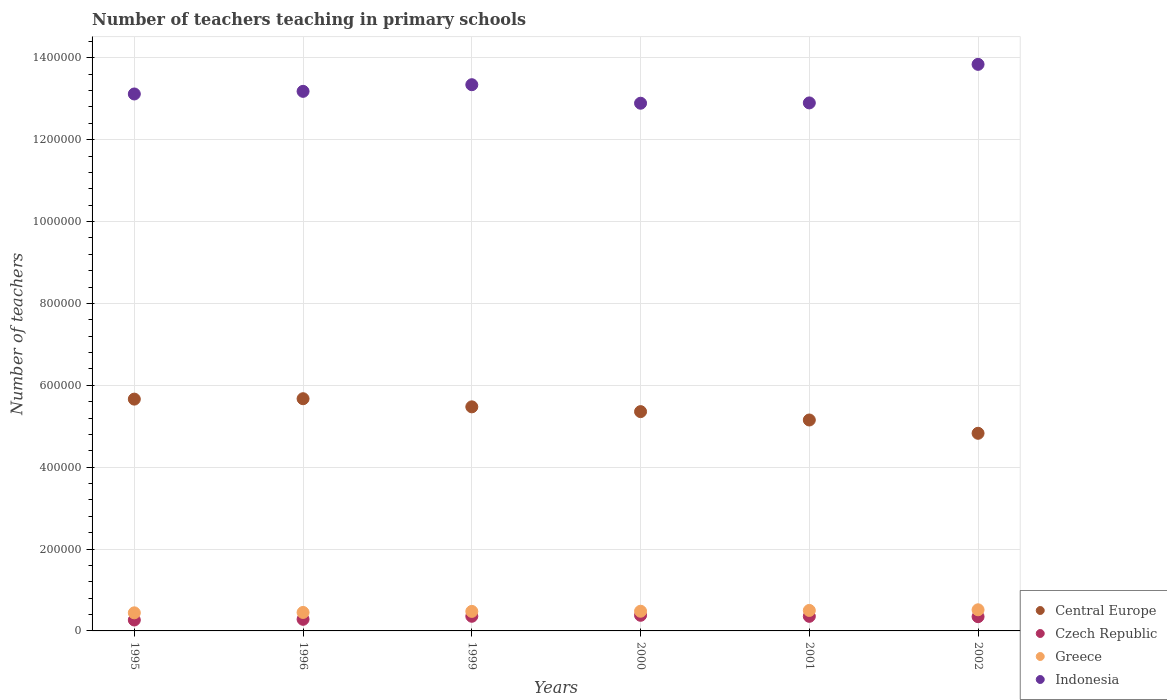Is the number of dotlines equal to the number of legend labels?
Make the answer very short. Yes. What is the number of teachers teaching in primary schools in Central Europe in 2001?
Offer a terse response. 5.15e+05. Across all years, what is the maximum number of teachers teaching in primary schools in Central Europe?
Give a very brief answer. 5.67e+05. Across all years, what is the minimum number of teachers teaching in primary schools in Central Europe?
Provide a succinct answer. 4.83e+05. In which year was the number of teachers teaching in primary schools in Greece minimum?
Give a very brief answer. 1995. What is the total number of teachers teaching in primary schools in Greece in the graph?
Give a very brief answer. 2.87e+05. What is the difference between the number of teachers teaching in primary schools in Indonesia in 1999 and that in 2000?
Make the answer very short. 4.52e+04. What is the difference between the number of teachers teaching in primary schools in Central Europe in 1995 and the number of teachers teaching in primary schools in Greece in 2000?
Your answer should be compact. 5.18e+05. What is the average number of teachers teaching in primary schools in Greece per year?
Ensure brevity in your answer.  4.78e+04. In the year 2001, what is the difference between the number of teachers teaching in primary schools in Czech Republic and number of teachers teaching in primary schools in Greece?
Provide a succinct answer. -1.44e+04. In how many years, is the number of teachers teaching in primary schools in Indonesia greater than 840000?
Ensure brevity in your answer.  6. What is the ratio of the number of teachers teaching in primary schools in Greece in 2001 to that in 2002?
Make the answer very short. 0.97. Is the difference between the number of teachers teaching in primary schools in Czech Republic in 1995 and 1996 greater than the difference between the number of teachers teaching in primary schools in Greece in 1995 and 1996?
Provide a succinct answer. No. What is the difference between the highest and the second highest number of teachers teaching in primary schools in Czech Republic?
Offer a terse response. 2410. What is the difference between the highest and the lowest number of teachers teaching in primary schools in Czech Republic?
Provide a short and direct response. 1.15e+04. Is it the case that in every year, the sum of the number of teachers teaching in primary schools in Greece and number of teachers teaching in primary schools in Central Europe  is greater than the sum of number of teachers teaching in primary schools in Czech Republic and number of teachers teaching in primary schools in Indonesia?
Ensure brevity in your answer.  Yes. Does the number of teachers teaching in primary schools in Indonesia monotonically increase over the years?
Your answer should be very brief. No. Is the number of teachers teaching in primary schools in Czech Republic strictly less than the number of teachers teaching in primary schools in Indonesia over the years?
Ensure brevity in your answer.  Yes. How many dotlines are there?
Provide a short and direct response. 4. How many years are there in the graph?
Your response must be concise. 6. What is the difference between two consecutive major ticks on the Y-axis?
Your answer should be compact. 2.00e+05. Does the graph contain grids?
Your response must be concise. Yes. What is the title of the graph?
Your response must be concise. Number of teachers teaching in primary schools. What is the label or title of the X-axis?
Ensure brevity in your answer.  Years. What is the label or title of the Y-axis?
Ensure brevity in your answer.  Number of teachers. What is the Number of teachers in Central Europe in 1995?
Provide a short and direct response. 5.66e+05. What is the Number of teachers of Czech Republic in 1995?
Provide a succinct answer. 2.67e+04. What is the Number of teachers in Greece in 1995?
Your answer should be compact. 4.42e+04. What is the Number of teachers in Indonesia in 1995?
Your answer should be compact. 1.31e+06. What is the Number of teachers of Central Europe in 1996?
Offer a terse response. 5.67e+05. What is the Number of teachers in Czech Republic in 1996?
Your response must be concise. 2.84e+04. What is the Number of teachers of Greece in 1996?
Your response must be concise. 4.51e+04. What is the Number of teachers in Indonesia in 1996?
Offer a terse response. 1.32e+06. What is the Number of teachers of Central Europe in 1999?
Ensure brevity in your answer.  5.47e+05. What is the Number of teachers of Czech Republic in 1999?
Your response must be concise. 3.58e+04. What is the Number of teachers of Greece in 1999?
Give a very brief answer. 4.77e+04. What is the Number of teachers of Indonesia in 1999?
Provide a short and direct response. 1.33e+06. What is the Number of teachers in Central Europe in 2000?
Keep it short and to the point. 5.36e+05. What is the Number of teachers in Czech Republic in 2000?
Your answer should be very brief. 3.82e+04. What is the Number of teachers of Greece in 2000?
Make the answer very short. 4.81e+04. What is the Number of teachers in Indonesia in 2000?
Provide a succinct answer. 1.29e+06. What is the Number of teachers of Central Europe in 2001?
Your response must be concise. 5.15e+05. What is the Number of teachers of Czech Republic in 2001?
Offer a terse response. 3.56e+04. What is the Number of teachers in Greece in 2001?
Give a very brief answer. 5.00e+04. What is the Number of teachers in Indonesia in 2001?
Make the answer very short. 1.29e+06. What is the Number of teachers of Central Europe in 2002?
Your answer should be very brief. 4.83e+05. What is the Number of teachers in Czech Republic in 2002?
Make the answer very short. 3.48e+04. What is the Number of teachers of Greece in 2002?
Your answer should be compact. 5.16e+04. What is the Number of teachers of Indonesia in 2002?
Your response must be concise. 1.38e+06. Across all years, what is the maximum Number of teachers in Central Europe?
Your answer should be very brief. 5.67e+05. Across all years, what is the maximum Number of teachers in Czech Republic?
Provide a succinct answer. 3.82e+04. Across all years, what is the maximum Number of teachers of Greece?
Keep it short and to the point. 5.16e+04. Across all years, what is the maximum Number of teachers in Indonesia?
Your answer should be compact. 1.38e+06. Across all years, what is the minimum Number of teachers of Central Europe?
Your answer should be compact. 4.83e+05. Across all years, what is the minimum Number of teachers in Czech Republic?
Offer a very short reply. 2.67e+04. Across all years, what is the minimum Number of teachers in Greece?
Provide a short and direct response. 4.42e+04. Across all years, what is the minimum Number of teachers in Indonesia?
Make the answer very short. 1.29e+06. What is the total Number of teachers in Central Europe in the graph?
Your answer should be very brief. 3.21e+06. What is the total Number of teachers in Czech Republic in the graph?
Offer a very short reply. 1.99e+05. What is the total Number of teachers of Greece in the graph?
Your response must be concise. 2.87e+05. What is the total Number of teachers of Indonesia in the graph?
Your answer should be very brief. 7.93e+06. What is the difference between the Number of teachers of Central Europe in 1995 and that in 1996?
Provide a short and direct response. -986.69. What is the difference between the Number of teachers of Czech Republic in 1995 and that in 1996?
Give a very brief answer. -1667. What is the difference between the Number of teachers in Greece in 1995 and that in 1996?
Make the answer very short. -960. What is the difference between the Number of teachers in Indonesia in 1995 and that in 1996?
Ensure brevity in your answer.  -6405. What is the difference between the Number of teachers of Central Europe in 1995 and that in 1999?
Your answer should be very brief. 1.89e+04. What is the difference between the Number of teachers of Czech Republic in 1995 and that in 1999?
Offer a terse response. -9097. What is the difference between the Number of teachers in Greece in 1995 and that in 1999?
Make the answer very short. -3516. What is the difference between the Number of teachers in Indonesia in 1995 and that in 1999?
Ensure brevity in your answer.  -2.26e+04. What is the difference between the Number of teachers in Central Europe in 1995 and that in 2000?
Keep it short and to the point. 3.05e+04. What is the difference between the Number of teachers in Czech Republic in 1995 and that in 2000?
Offer a very short reply. -1.15e+04. What is the difference between the Number of teachers of Greece in 1995 and that in 2000?
Offer a very short reply. -3936. What is the difference between the Number of teachers in Indonesia in 1995 and that in 2000?
Offer a very short reply. 2.26e+04. What is the difference between the Number of teachers of Central Europe in 1995 and that in 2001?
Ensure brevity in your answer.  5.10e+04. What is the difference between the Number of teachers in Czech Republic in 1995 and that in 2001?
Offer a terse response. -8922. What is the difference between the Number of teachers of Greece in 1995 and that in 2001?
Give a very brief answer. -5844. What is the difference between the Number of teachers in Indonesia in 1995 and that in 2001?
Your response must be concise. 2.19e+04. What is the difference between the Number of teachers in Central Europe in 1995 and that in 2002?
Make the answer very short. 8.35e+04. What is the difference between the Number of teachers of Czech Republic in 1995 and that in 2002?
Offer a very short reply. -8106. What is the difference between the Number of teachers in Greece in 1995 and that in 2002?
Your response must be concise. -7438. What is the difference between the Number of teachers in Indonesia in 1995 and that in 2002?
Offer a very short reply. -7.23e+04. What is the difference between the Number of teachers of Central Europe in 1996 and that in 1999?
Give a very brief answer. 1.99e+04. What is the difference between the Number of teachers in Czech Republic in 1996 and that in 1999?
Your response must be concise. -7430. What is the difference between the Number of teachers in Greece in 1996 and that in 1999?
Provide a short and direct response. -2556. What is the difference between the Number of teachers in Indonesia in 1996 and that in 1999?
Offer a terse response. -1.62e+04. What is the difference between the Number of teachers in Central Europe in 1996 and that in 2000?
Provide a short and direct response. 3.15e+04. What is the difference between the Number of teachers of Czech Republic in 1996 and that in 2000?
Give a very brief answer. -9840. What is the difference between the Number of teachers in Greece in 1996 and that in 2000?
Offer a terse response. -2976. What is the difference between the Number of teachers of Indonesia in 1996 and that in 2000?
Keep it short and to the point. 2.90e+04. What is the difference between the Number of teachers of Central Europe in 1996 and that in 2001?
Keep it short and to the point. 5.20e+04. What is the difference between the Number of teachers of Czech Republic in 1996 and that in 2001?
Offer a very short reply. -7255. What is the difference between the Number of teachers of Greece in 1996 and that in 2001?
Ensure brevity in your answer.  -4884. What is the difference between the Number of teachers in Indonesia in 1996 and that in 2001?
Give a very brief answer. 2.83e+04. What is the difference between the Number of teachers of Central Europe in 1996 and that in 2002?
Your response must be concise. 8.45e+04. What is the difference between the Number of teachers in Czech Republic in 1996 and that in 2002?
Ensure brevity in your answer.  -6439. What is the difference between the Number of teachers of Greece in 1996 and that in 2002?
Your answer should be compact. -6478. What is the difference between the Number of teachers in Indonesia in 1996 and that in 2002?
Your response must be concise. -6.59e+04. What is the difference between the Number of teachers of Central Europe in 1999 and that in 2000?
Your answer should be compact. 1.17e+04. What is the difference between the Number of teachers in Czech Republic in 1999 and that in 2000?
Keep it short and to the point. -2410. What is the difference between the Number of teachers in Greece in 1999 and that in 2000?
Your response must be concise. -420. What is the difference between the Number of teachers in Indonesia in 1999 and that in 2000?
Offer a very short reply. 4.52e+04. What is the difference between the Number of teachers in Central Europe in 1999 and that in 2001?
Your answer should be very brief. 3.21e+04. What is the difference between the Number of teachers of Czech Republic in 1999 and that in 2001?
Your answer should be very brief. 175. What is the difference between the Number of teachers in Greece in 1999 and that in 2001?
Provide a succinct answer. -2328. What is the difference between the Number of teachers in Indonesia in 1999 and that in 2001?
Your response must be concise. 4.45e+04. What is the difference between the Number of teachers of Central Europe in 1999 and that in 2002?
Offer a very short reply. 6.46e+04. What is the difference between the Number of teachers of Czech Republic in 1999 and that in 2002?
Give a very brief answer. 991. What is the difference between the Number of teachers in Greece in 1999 and that in 2002?
Provide a short and direct response. -3922. What is the difference between the Number of teachers in Indonesia in 1999 and that in 2002?
Give a very brief answer. -4.97e+04. What is the difference between the Number of teachers in Central Europe in 2000 and that in 2001?
Offer a terse response. 2.04e+04. What is the difference between the Number of teachers in Czech Republic in 2000 and that in 2001?
Give a very brief answer. 2585. What is the difference between the Number of teachers in Greece in 2000 and that in 2001?
Provide a succinct answer. -1908. What is the difference between the Number of teachers of Indonesia in 2000 and that in 2001?
Make the answer very short. -755. What is the difference between the Number of teachers of Central Europe in 2000 and that in 2002?
Ensure brevity in your answer.  5.29e+04. What is the difference between the Number of teachers in Czech Republic in 2000 and that in 2002?
Ensure brevity in your answer.  3401. What is the difference between the Number of teachers of Greece in 2000 and that in 2002?
Offer a very short reply. -3502. What is the difference between the Number of teachers in Indonesia in 2000 and that in 2002?
Keep it short and to the point. -9.49e+04. What is the difference between the Number of teachers of Central Europe in 2001 and that in 2002?
Keep it short and to the point. 3.25e+04. What is the difference between the Number of teachers in Czech Republic in 2001 and that in 2002?
Your answer should be compact. 816. What is the difference between the Number of teachers of Greece in 2001 and that in 2002?
Provide a succinct answer. -1594. What is the difference between the Number of teachers in Indonesia in 2001 and that in 2002?
Make the answer very short. -9.42e+04. What is the difference between the Number of teachers of Central Europe in 1995 and the Number of teachers of Czech Republic in 1996?
Offer a very short reply. 5.38e+05. What is the difference between the Number of teachers in Central Europe in 1995 and the Number of teachers in Greece in 1996?
Provide a short and direct response. 5.21e+05. What is the difference between the Number of teachers in Central Europe in 1995 and the Number of teachers in Indonesia in 1996?
Keep it short and to the point. -7.52e+05. What is the difference between the Number of teachers in Czech Republic in 1995 and the Number of teachers in Greece in 1996?
Provide a short and direct response. -1.84e+04. What is the difference between the Number of teachers of Czech Republic in 1995 and the Number of teachers of Indonesia in 1996?
Give a very brief answer. -1.29e+06. What is the difference between the Number of teachers of Greece in 1995 and the Number of teachers of Indonesia in 1996?
Provide a succinct answer. -1.27e+06. What is the difference between the Number of teachers of Central Europe in 1995 and the Number of teachers of Czech Republic in 1999?
Your response must be concise. 5.30e+05. What is the difference between the Number of teachers of Central Europe in 1995 and the Number of teachers of Greece in 1999?
Your answer should be very brief. 5.19e+05. What is the difference between the Number of teachers in Central Europe in 1995 and the Number of teachers in Indonesia in 1999?
Your answer should be compact. -7.68e+05. What is the difference between the Number of teachers of Czech Republic in 1995 and the Number of teachers of Greece in 1999?
Offer a terse response. -2.10e+04. What is the difference between the Number of teachers in Czech Republic in 1995 and the Number of teachers in Indonesia in 1999?
Your answer should be compact. -1.31e+06. What is the difference between the Number of teachers in Greece in 1995 and the Number of teachers in Indonesia in 1999?
Ensure brevity in your answer.  -1.29e+06. What is the difference between the Number of teachers of Central Europe in 1995 and the Number of teachers of Czech Republic in 2000?
Your answer should be compact. 5.28e+05. What is the difference between the Number of teachers of Central Europe in 1995 and the Number of teachers of Greece in 2000?
Provide a succinct answer. 5.18e+05. What is the difference between the Number of teachers of Central Europe in 1995 and the Number of teachers of Indonesia in 2000?
Make the answer very short. -7.23e+05. What is the difference between the Number of teachers in Czech Republic in 1995 and the Number of teachers in Greece in 2000?
Your answer should be compact. -2.14e+04. What is the difference between the Number of teachers of Czech Republic in 1995 and the Number of teachers of Indonesia in 2000?
Your answer should be compact. -1.26e+06. What is the difference between the Number of teachers of Greece in 1995 and the Number of teachers of Indonesia in 2000?
Keep it short and to the point. -1.24e+06. What is the difference between the Number of teachers in Central Europe in 1995 and the Number of teachers in Czech Republic in 2001?
Your answer should be compact. 5.31e+05. What is the difference between the Number of teachers in Central Europe in 1995 and the Number of teachers in Greece in 2001?
Provide a short and direct response. 5.16e+05. What is the difference between the Number of teachers in Central Europe in 1995 and the Number of teachers in Indonesia in 2001?
Your response must be concise. -7.24e+05. What is the difference between the Number of teachers in Czech Republic in 1995 and the Number of teachers in Greece in 2001?
Offer a very short reply. -2.33e+04. What is the difference between the Number of teachers in Czech Republic in 1995 and the Number of teachers in Indonesia in 2001?
Offer a terse response. -1.26e+06. What is the difference between the Number of teachers in Greece in 1995 and the Number of teachers in Indonesia in 2001?
Make the answer very short. -1.25e+06. What is the difference between the Number of teachers in Central Europe in 1995 and the Number of teachers in Czech Republic in 2002?
Make the answer very short. 5.31e+05. What is the difference between the Number of teachers in Central Europe in 1995 and the Number of teachers in Greece in 2002?
Ensure brevity in your answer.  5.15e+05. What is the difference between the Number of teachers of Central Europe in 1995 and the Number of teachers of Indonesia in 2002?
Provide a succinct answer. -8.18e+05. What is the difference between the Number of teachers of Czech Republic in 1995 and the Number of teachers of Greece in 2002?
Provide a short and direct response. -2.49e+04. What is the difference between the Number of teachers of Czech Republic in 1995 and the Number of teachers of Indonesia in 2002?
Offer a terse response. -1.36e+06. What is the difference between the Number of teachers of Greece in 1995 and the Number of teachers of Indonesia in 2002?
Offer a very short reply. -1.34e+06. What is the difference between the Number of teachers of Central Europe in 1996 and the Number of teachers of Czech Republic in 1999?
Give a very brief answer. 5.31e+05. What is the difference between the Number of teachers in Central Europe in 1996 and the Number of teachers in Greece in 1999?
Your answer should be compact. 5.20e+05. What is the difference between the Number of teachers of Central Europe in 1996 and the Number of teachers of Indonesia in 1999?
Provide a succinct answer. -7.67e+05. What is the difference between the Number of teachers in Czech Republic in 1996 and the Number of teachers in Greece in 1999?
Give a very brief answer. -1.93e+04. What is the difference between the Number of teachers of Czech Republic in 1996 and the Number of teachers of Indonesia in 1999?
Offer a terse response. -1.31e+06. What is the difference between the Number of teachers in Greece in 1996 and the Number of teachers in Indonesia in 1999?
Provide a short and direct response. -1.29e+06. What is the difference between the Number of teachers in Central Europe in 1996 and the Number of teachers in Czech Republic in 2000?
Provide a short and direct response. 5.29e+05. What is the difference between the Number of teachers in Central Europe in 1996 and the Number of teachers in Greece in 2000?
Make the answer very short. 5.19e+05. What is the difference between the Number of teachers in Central Europe in 1996 and the Number of teachers in Indonesia in 2000?
Offer a very short reply. -7.22e+05. What is the difference between the Number of teachers in Czech Republic in 1996 and the Number of teachers in Greece in 2000?
Give a very brief answer. -1.97e+04. What is the difference between the Number of teachers of Czech Republic in 1996 and the Number of teachers of Indonesia in 2000?
Your answer should be compact. -1.26e+06. What is the difference between the Number of teachers of Greece in 1996 and the Number of teachers of Indonesia in 2000?
Keep it short and to the point. -1.24e+06. What is the difference between the Number of teachers of Central Europe in 1996 and the Number of teachers of Czech Republic in 2001?
Provide a succinct answer. 5.32e+05. What is the difference between the Number of teachers in Central Europe in 1996 and the Number of teachers in Greece in 2001?
Provide a short and direct response. 5.17e+05. What is the difference between the Number of teachers of Central Europe in 1996 and the Number of teachers of Indonesia in 2001?
Keep it short and to the point. -7.23e+05. What is the difference between the Number of teachers in Czech Republic in 1996 and the Number of teachers in Greece in 2001?
Keep it short and to the point. -2.17e+04. What is the difference between the Number of teachers of Czech Republic in 1996 and the Number of teachers of Indonesia in 2001?
Give a very brief answer. -1.26e+06. What is the difference between the Number of teachers in Greece in 1996 and the Number of teachers in Indonesia in 2001?
Keep it short and to the point. -1.24e+06. What is the difference between the Number of teachers of Central Europe in 1996 and the Number of teachers of Czech Republic in 2002?
Make the answer very short. 5.32e+05. What is the difference between the Number of teachers in Central Europe in 1996 and the Number of teachers in Greece in 2002?
Make the answer very short. 5.16e+05. What is the difference between the Number of teachers in Central Europe in 1996 and the Number of teachers in Indonesia in 2002?
Make the answer very short. -8.17e+05. What is the difference between the Number of teachers in Czech Republic in 1996 and the Number of teachers in Greece in 2002?
Your answer should be very brief. -2.32e+04. What is the difference between the Number of teachers of Czech Republic in 1996 and the Number of teachers of Indonesia in 2002?
Your answer should be very brief. -1.36e+06. What is the difference between the Number of teachers in Greece in 1996 and the Number of teachers in Indonesia in 2002?
Make the answer very short. -1.34e+06. What is the difference between the Number of teachers of Central Europe in 1999 and the Number of teachers of Czech Republic in 2000?
Make the answer very short. 5.09e+05. What is the difference between the Number of teachers in Central Europe in 1999 and the Number of teachers in Greece in 2000?
Offer a terse response. 4.99e+05. What is the difference between the Number of teachers of Central Europe in 1999 and the Number of teachers of Indonesia in 2000?
Your answer should be very brief. -7.42e+05. What is the difference between the Number of teachers of Czech Republic in 1999 and the Number of teachers of Greece in 2000?
Ensure brevity in your answer.  -1.23e+04. What is the difference between the Number of teachers of Czech Republic in 1999 and the Number of teachers of Indonesia in 2000?
Provide a succinct answer. -1.25e+06. What is the difference between the Number of teachers in Greece in 1999 and the Number of teachers in Indonesia in 2000?
Your answer should be compact. -1.24e+06. What is the difference between the Number of teachers in Central Europe in 1999 and the Number of teachers in Czech Republic in 2001?
Your answer should be very brief. 5.12e+05. What is the difference between the Number of teachers of Central Europe in 1999 and the Number of teachers of Greece in 2001?
Make the answer very short. 4.97e+05. What is the difference between the Number of teachers of Central Europe in 1999 and the Number of teachers of Indonesia in 2001?
Ensure brevity in your answer.  -7.42e+05. What is the difference between the Number of teachers in Czech Republic in 1999 and the Number of teachers in Greece in 2001?
Make the answer very short. -1.42e+04. What is the difference between the Number of teachers of Czech Republic in 1999 and the Number of teachers of Indonesia in 2001?
Provide a short and direct response. -1.25e+06. What is the difference between the Number of teachers in Greece in 1999 and the Number of teachers in Indonesia in 2001?
Offer a terse response. -1.24e+06. What is the difference between the Number of teachers of Central Europe in 1999 and the Number of teachers of Czech Republic in 2002?
Provide a succinct answer. 5.13e+05. What is the difference between the Number of teachers in Central Europe in 1999 and the Number of teachers in Greece in 2002?
Offer a very short reply. 4.96e+05. What is the difference between the Number of teachers in Central Europe in 1999 and the Number of teachers in Indonesia in 2002?
Your answer should be very brief. -8.37e+05. What is the difference between the Number of teachers in Czech Republic in 1999 and the Number of teachers in Greece in 2002?
Ensure brevity in your answer.  -1.58e+04. What is the difference between the Number of teachers in Czech Republic in 1999 and the Number of teachers in Indonesia in 2002?
Offer a very short reply. -1.35e+06. What is the difference between the Number of teachers in Greece in 1999 and the Number of teachers in Indonesia in 2002?
Ensure brevity in your answer.  -1.34e+06. What is the difference between the Number of teachers in Central Europe in 2000 and the Number of teachers in Czech Republic in 2001?
Provide a short and direct response. 5.00e+05. What is the difference between the Number of teachers of Central Europe in 2000 and the Number of teachers of Greece in 2001?
Make the answer very short. 4.86e+05. What is the difference between the Number of teachers in Central Europe in 2000 and the Number of teachers in Indonesia in 2001?
Offer a terse response. -7.54e+05. What is the difference between the Number of teachers in Czech Republic in 2000 and the Number of teachers in Greece in 2001?
Provide a short and direct response. -1.18e+04. What is the difference between the Number of teachers of Czech Republic in 2000 and the Number of teachers of Indonesia in 2001?
Give a very brief answer. -1.25e+06. What is the difference between the Number of teachers in Greece in 2000 and the Number of teachers in Indonesia in 2001?
Offer a very short reply. -1.24e+06. What is the difference between the Number of teachers in Central Europe in 2000 and the Number of teachers in Czech Republic in 2002?
Provide a succinct answer. 5.01e+05. What is the difference between the Number of teachers of Central Europe in 2000 and the Number of teachers of Greece in 2002?
Ensure brevity in your answer.  4.84e+05. What is the difference between the Number of teachers in Central Europe in 2000 and the Number of teachers in Indonesia in 2002?
Provide a short and direct response. -8.48e+05. What is the difference between the Number of teachers in Czech Republic in 2000 and the Number of teachers in Greece in 2002?
Ensure brevity in your answer.  -1.34e+04. What is the difference between the Number of teachers of Czech Republic in 2000 and the Number of teachers of Indonesia in 2002?
Provide a succinct answer. -1.35e+06. What is the difference between the Number of teachers in Greece in 2000 and the Number of teachers in Indonesia in 2002?
Ensure brevity in your answer.  -1.34e+06. What is the difference between the Number of teachers of Central Europe in 2001 and the Number of teachers of Czech Republic in 2002?
Your response must be concise. 4.80e+05. What is the difference between the Number of teachers in Central Europe in 2001 and the Number of teachers in Greece in 2002?
Your response must be concise. 4.64e+05. What is the difference between the Number of teachers in Central Europe in 2001 and the Number of teachers in Indonesia in 2002?
Provide a succinct answer. -8.69e+05. What is the difference between the Number of teachers of Czech Republic in 2001 and the Number of teachers of Greece in 2002?
Your answer should be very brief. -1.60e+04. What is the difference between the Number of teachers in Czech Republic in 2001 and the Number of teachers in Indonesia in 2002?
Your answer should be very brief. -1.35e+06. What is the difference between the Number of teachers in Greece in 2001 and the Number of teachers in Indonesia in 2002?
Make the answer very short. -1.33e+06. What is the average Number of teachers of Central Europe per year?
Your answer should be very brief. 5.36e+05. What is the average Number of teachers of Czech Republic per year?
Your response must be concise. 3.32e+04. What is the average Number of teachers of Greece per year?
Make the answer very short. 4.78e+04. What is the average Number of teachers of Indonesia per year?
Your response must be concise. 1.32e+06. In the year 1995, what is the difference between the Number of teachers in Central Europe and Number of teachers in Czech Republic?
Your answer should be compact. 5.40e+05. In the year 1995, what is the difference between the Number of teachers in Central Europe and Number of teachers in Greece?
Offer a terse response. 5.22e+05. In the year 1995, what is the difference between the Number of teachers of Central Europe and Number of teachers of Indonesia?
Provide a short and direct response. -7.45e+05. In the year 1995, what is the difference between the Number of teachers in Czech Republic and Number of teachers in Greece?
Your response must be concise. -1.75e+04. In the year 1995, what is the difference between the Number of teachers of Czech Republic and Number of teachers of Indonesia?
Your answer should be compact. -1.28e+06. In the year 1995, what is the difference between the Number of teachers in Greece and Number of teachers in Indonesia?
Offer a very short reply. -1.27e+06. In the year 1996, what is the difference between the Number of teachers of Central Europe and Number of teachers of Czech Republic?
Provide a succinct answer. 5.39e+05. In the year 1996, what is the difference between the Number of teachers of Central Europe and Number of teachers of Greece?
Provide a short and direct response. 5.22e+05. In the year 1996, what is the difference between the Number of teachers in Central Europe and Number of teachers in Indonesia?
Provide a short and direct response. -7.51e+05. In the year 1996, what is the difference between the Number of teachers in Czech Republic and Number of teachers in Greece?
Your answer should be compact. -1.68e+04. In the year 1996, what is the difference between the Number of teachers in Czech Republic and Number of teachers in Indonesia?
Provide a succinct answer. -1.29e+06. In the year 1996, what is the difference between the Number of teachers of Greece and Number of teachers of Indonesia?
Offer a very short reply. -1.27e+06. In the year 1999, what is the difference between the Number of teachers of Central Europe and Number of teachers of Czech Republic?
Make the answer very short. 5.12e+05. In the year 1999, what is the difference between the Number of teachers of Central Europe and Number of teachers of Greece?
Your answer should be compact. 5.00e+05. In the year 1999, what is the difference between the Number of teachers in Central Europe and Number of teachers in Indonesia?
Provide a short and direct response. -7.87e+05. In the year 1999, what is the difference between the Number of teachers of Czech Republic and Number of teachers of Greece?
Provide a succinct answer. -1.19e+04. In the year 1999, what is the difference between the Number of teachers in Czech Republic and Number of teachers in Indonesia?
Offer a very short reply. -1.30e+06. In the year 1999, what is the difference between the Number of teachers in Greece and Number of teachers in Indonesia?
Make the answer very short. -1.29e+06. In the year 2000, what is the difference between the Number of teachers of Central Europe and Number of teachers of Czech Republic?
Offer a very short reply. 4.97e+05. In the year 2000, what is the difference between the Number of teachers in Central Europe and Number of teachers in Greece?
Offer a terse response. 4.88e+05. In the year 2000, what is the difference between the Number of teachers of Central Europe and Number of teachers of Indonesia?
Your answer should be compact. -7.53e+05. In the year 2000, what is the difference between the Number of teachers of Czech Republic and Number of teachers of Greece?
Provide a short and direct response. -9908. In the year 2000, what is the difference between the Number of teachers in Czech Republic and Number of teachers in Indonesia?
Give a very brief answer. -1.25e+06. In the year 2000, what is the difference between the Number of teachers in Greece and Number of teachers in Indonesia?
Offer a terse response. -1.24e+06. In the year 2001, what is the difference between the Number of teachers in Central Europe and Number of teachers in Czech Republic?
Keep it short and to the point. 4.80e+05. In the year 2001, what is the difference between the Number of teachers of Central Europe and Number of teachers of Greece?
Your response must be concise. 4.65e+05. In the year 2001, what is the difference between the Number of teachers in Central Europe and Number of teachers in Indonesia?
Ensure brevity in your answer.  -7.74e+05. In the year 2001, what is the difference between the Number of teachers in Czech Republic and Number of teachers in Greece?
Make the answer very short. -1.44e+04. In the year 2001, what is the difference between the Number of teachers in Czech Republic and Number of teachers in Indonesia?
Your answer should be very brief. -1.25e+06. In the year 2001, what is the difference between the Number of teachers of Greece and Number of teachers of Indonesia?
Give a very brief answer. -1.24e+06. In the year 2002, what is the difference between the Number of teachers of Central Europe and Number of teachers of Czech Republic?
Provide a short and direct response. 4.48e+05. In the year 2002, what is the difference between the Number of teachers of Central Europe and Number of teachers of Greece?
Your response must be concise. 4.31e+05. In the year 2002, what is the difference between the Number of teachers in Central Europe and Number of teachers in Indonesia?
Ensure brevity in your answer.  -9.01e+05. In the year 2002, what is the difference between the Number of teachers in Czech Republic and Number of teachers in Greece?
Keep it short and to the point. -1.68e+04. In the year 2002, what is the difference between the Number of teachers in Czech Republic and Number of teachers in Indonesia?
Provide a short and direct response. -1.35e+06. In the year 2002, what is the difference between the Number of teachers in Greece and Number of teachers in Indonesia?
Your answer should be compact. -1.33e+06. What is the ratio of the Number of teachers in Greece in 1995 to that in 1996?
Provide a succinct answer. 0.98. What is the ratio of the Number of teachers in Indonesia in 1995 to that in 1996?
Make the answer very short. 1. What is the ratio of the Number of teachers in Central Europe in 1995 to that in 1999?
Keep it short and to the point. 1.03. What is the ratio of the Number of teachers in Czech Republic in 1995 to that in 1999?
Give a very brief answer. 0.75. What is the ratio of the Number of teachers in Greece in 1995 to that in 1999?
Offer a terse response. 0.93. What is the ratio of the Number of teachers of Indonesia in 1995 to that in 1999?
Give a very brief answer. 0.98. What is the ratio of the Number of teachers of Central Europe in 1995 to that in 2000?
Ensure brevity in your answer.  1.06. What is the ratio of the Number of teachers in Czech Republic in 1995 to that in 2000?
Your answer should be compact. 0.7. What is the ratio of the Number of teachers of Greece in 1995 to that in 2000?
Provide a succinct answer. 0.92. What is the ratio of the Number of teachers in Indonesia in 1995 to that in 2000?
Give a very brief answer. 1.02. What is the ratio of the Number of teachers of Central Europe in 1995 to that in 2001?
Your response must be concise. 1.1. What is the ratio of the Number of teachers in Czech Republic in 1995 to that in 2001?
Keep it short and to the point. 0.75. What is the ratio of the Number of teachers of Greece in 1995 to that in 2001?
Make the answer very short. 0.88. What is the ratio of the Number of teachers in Indonesia in 1995 to that in 2001?
Provide a short and direct response. 1.02. What is the ratio of the Number of teachers of Central Europe in 1995 to that in 2002?
Provide a succinct answer. 1.17. What is the ratio of the Number of teachers of Czech Republic in 1995 to that in 2002?
Give a very brief answer. 0.77. What is the ratio of the Number of teachers of Greece in 1995 to that in 2002?
Offer a terse response. 0.86. What is the ratio of the Number of teachers of Indonesia in 1995 to that in 2002?
Ensure brevity in your answer.  0.95. What is the ratio of the Number of teachers of Central Europe in 1996 to that in 1999?
Your answer should be compact. 1.04. What is the ratio of the Number of teachers in Czech Republic in 1996 to that in 1999?
Provide a short and direct response. 0.79. What is the ratio of the Number of teachers in Greece in 1996 to that in 1999?
Provide a succinct answer. 0.95. What is the ratio of the Number of teachers in Indonesia in 1996 to that in 1999?
Give a very brief answer. 0.99. What is the ratio of the Number of teachers in Central Europe in 1996 to that in 2000?
Give a very brief answer. 1.06. What is the ratio of the Number of teachers of Czech Republic in 1996 to that in 2000?
Make the answer very short. 0.74. What is the ratio of the Number of teachers of Greece in 1996 to that in 2000?
Your answer should be very brief. 0.94. What is the ratio of the Number of teachers of Indonesia in 1996 to that in 2000?
Keep it short and to the point. 1.02. What is the ratio of the Number of teachers of Central Europe in 1996 to that in 2001?
Your answer should be very brief. 1.1. What is the ratio of the Number of teachers of Czech Republic in 1996 to that in 2001?
Provide a succinct answer. 0.8. What is the ratio of the Number of teachers in Greece in 1996 to that in 2001?
Provide a succinct answer. 0.9. What is the ratio of the Number of teachers of Indonesia in 1996 to that in 2001?
Provide a succinct answer. 1.02. What is the ratio of the Number of teachers in Central Europe in 1996 to that in 2002?
Provide a succinct answer. 1.17. What is the ratio of the Number of teachers of Czech Republic in 1996 to that in 2002?
Your answer should be compact. 0.81. What is the ratio of the Number of teachers of Greece in 1996 to that in 2002?
Make the answer very short. 0.87. What is the ratio of the Number of teachers of Central Europe in 1999 to that in 2000?
Make the answer very short. 1.02. What is the ratio of the Number of teachers of Czech Republic in 1999 to that in 2000?
Offer a terse response. 0.94. What is the ratio of the Number of teachers in Greece in 1999 to that in 2000?
Keep it short and to the point. 0.99. What is the ratio of the Number of teachers in Indonesia in 1999 to that in 2000?
Offer a terse response. 1.04. What is the ratio of the Number of teachers of Central Europe in 1999 to that in 2001?
Your response must be concise. 1.06. What is the ratio of the Number of teachers of Greece in 1999 to that in 2001?
Ensure brevity in your answer.  0.95. What is the ratio of the Number of teachers of Indonesia in 1999 to that in 2001?
Your response must be concise. 1.03. What is the ratio of the Number of teachers of Central Europe in 1999 to that in 2002?
Offer a very short reply. 1.13. What is the ratio of the Number of teachers of Czech Republic in 1999 to that in 2002?
Provide a short and direct response. 1.03. What is the ratio of the Number of teachers in Greece in 1999 to that in 2002?
Make the answer very short. 0.92. What is the ratio of the Number of teachers in Indonesia in 1999 to that in 2002?
Your response must be concise. 0.96. What is the ratio of the Number of teachers in Central Europe in 2000 to that in 2001?
Your answer should be compact. 1.04. What is the ratio of the Number of teachers of Czech Republic in 2000 to that in 2001?
Your answer should be compact. 1.07. What is the ratio of the Number of teachers of Greece in 2000 to that in 2001?
Give a very brief answer. 0.96. What is the ratio of the Number of teachers of Indonesia in 2000 to that in 2001?
Offer a very short reply. 1. What is the ratio of the Number of teachers of Central Europe in 2000 to that in 2002?
Keep it short and to the point. 1.11. What is the ratio of the Number of teachers in Czech Republic in 2000 to that in 2002?
Your answer should be very brief. 1.1. What is the ratio of the Number of teachers in Greece in 2000 to that in 2002?
Keep it short and to the point. 0.93. What is the ratio of the Number of teachers in Indonesia in 2000 to that in 2002?
Offer a very short reply. 0.93. What is the ratio of the Number of teachers in Central Europe in 2001 to that in 2002?
Keep it short and to the point. 1.07. What is the ratio of the Number of teachers of Czech Republic in 2001 to that in 2002?
Provide a short and direct response. 1.02. What is the ratio of the Number of teachers of Greece in 2001 to that in 2002?
Make the answer very short. 0.97. What is the ratio of the Number of teachers of Indonesia in 2001 to that in 2002?
Keep it short and to the point. 0.93. What is the difference between the highest and the second highest Number of teachers in Central Europe?
Offer a very short reply. 986.69. What is the difference between the highest and the second highest Number of teachers of Czech Republic?
Give a very brief answer. 2410. What is the difference between the highest and the second highest Number of teachers in Greece?
Keep it short and to the point. 1594. What is the difference between the highest and the second highest Number of teachers in Indonesia?
Offer a very short reply. 4.97e+04. What is the difference between the highest and the lowest Number of teachers in Central Europe?
Make the answer very short. 8.45e+04. What is the difference between the highest and the lowest Number of teachers in Czech Republic?
Offer a terse response. 1.15e+04. What is the difference between the highest and the lowest Number of teachers in Greece?
Make the answer very short. 7438. What is the difference between the highest and the lowest Number of teachers of Indonesia?
Your answer should be compact. 9.49e+04. 